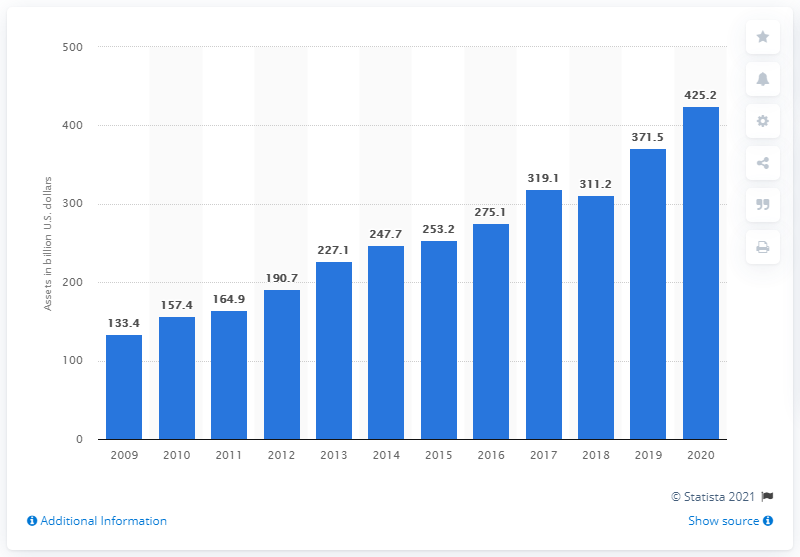Indicate a few pertinent items in this graphic. As of December 31, 2020, the total value of the section 529 savings plan was $425.2. 